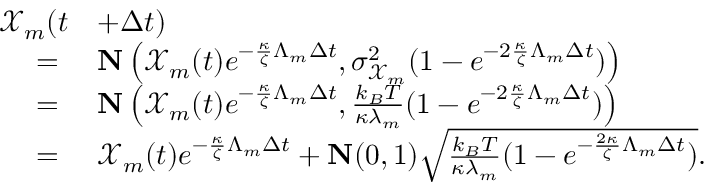Convert formula to latex. <formula><loc_0><loc_0><loc_500><loc_500>\begin{array} { r l } { \mathcal { X } _ { m } ( t } & { + \Delta t ) } \\ { = } & { N \left ( \mathcal { X } _ { m } ( t ) e ^ { - \frac { \kappa } { \zeta } \Lambda _ { m } \Delta t } , \sigma _ { \mathcal { X } _ { m } } ^ { 2 } ( 1 - e ^ { - 2 \frac { \kappa } { \zeta } \Lambda _ { m } \Delta t } ) \right ) } \\ { = } & { N \left ( \mathcal { X } _ { m } ( t ) e ^ { - \frac { \kappa } { \zeta } \Lambda _ { m } \Delta t } , \frac { k _ { B } T } { \kappa \lambda _ { m } } ( 1 - e ^ { - 2 \frac { \kappa } { \zeta } \Lambda _ { m } \Delta t } ) \right ) } \\ { = } & { \mathcal { X } _ { m } ( t ) e ^ { - \frac { \kappa } { \zeta } \Lambda _ { m } \Delta t } + N ( 0 , 1 ) \sqrt { \frac { k _ { B } T } { \kappa { \lambda } _ { m } } ( 1 - e ^ { - \frac { 2 \kappa } { \zeta } \Lambda _ { m } \Delta t } ) } . } \end{array}</formula> 